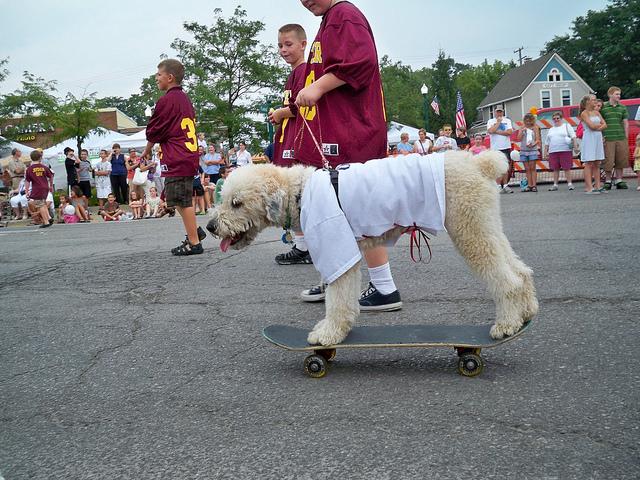Is the dog dry?
Give a very brief answer. Yes. What is the dog on?
Answer briefly. Skateboard. Do you see a man with a green shirt?
Give a very brief answer. Yes. Is there a car behind the dog?
Keep it brief. No. Is the dog dressed up?
Keep it brief. Yes. 